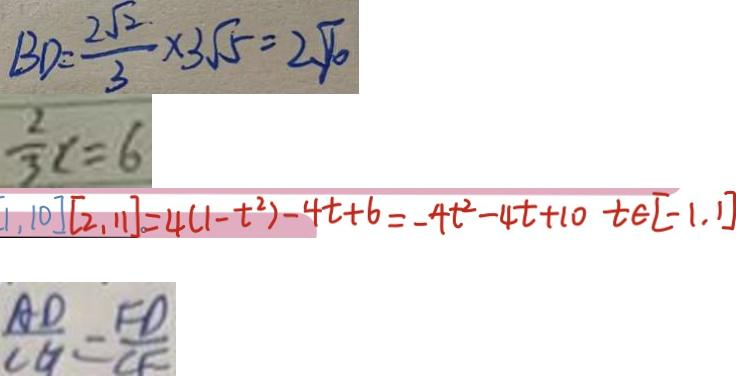<formula> <loc_0><loc_0><loc_500><loc_500>B D = \frac { 2 \sqrt { 2 } } { 3 } \times 3 \sqrt { 5 } = 2 \sqrt { 1 0 } 
 \frac { 2 } { 3 } x = 6 
 [ 1 , 1 0 ] [ 2 , 1 1 ] = 4 ( 1 - t ^ { 2 } ) - 4 t + 6 = - 4 t ^ { 2 } - 4 t + 1 0 t \int [ - 1 , 1 ] 
 \frac { A D } { C G } = \frac { F D } { C F }</formula> 